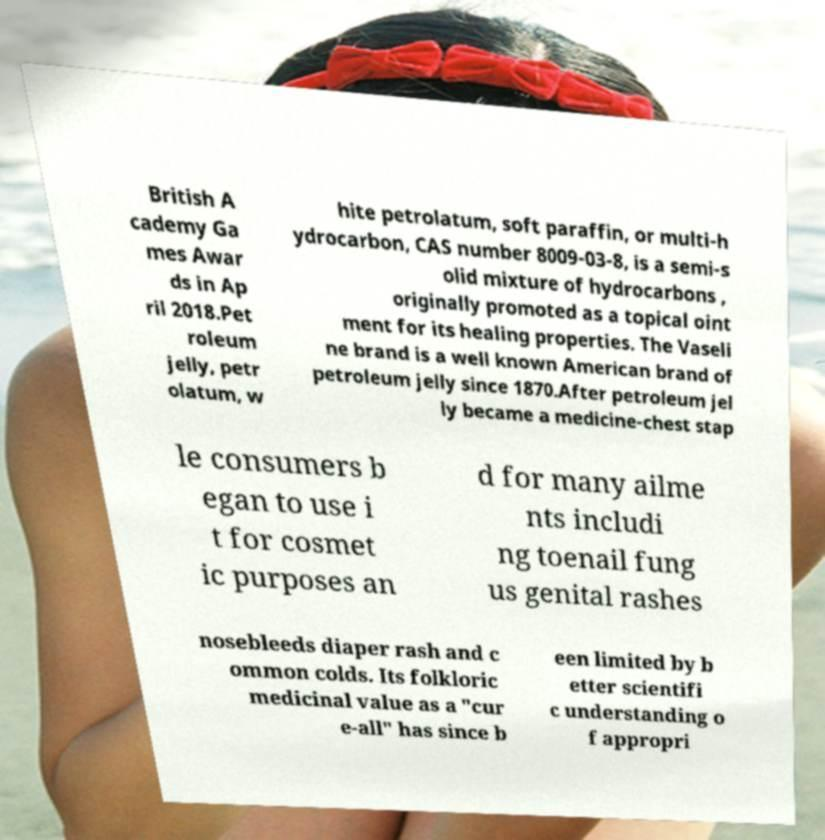Can you accurately transcribe the text from the provided image for me? British A cademy Ga mes Awar ds in Ap ril 2018.Pet roleum jelly, petr olatum, w hite petrolatum, soft paraffin, or multi-h ydrocarbon, CAS number 8009-03-8, is a semi-s olid mixture of hydrocarbons , originally promoted as a topical oint ment for its healing properties. The Vaseli ne brand is a well known American brand of petroleum jelly since 1870.After petroleum jel ly became a medicine-chest stap le consumers b egan to use i t for cosmet ic purposes an d for many ailme nts includi ng toenail fung us genital rashes nosebleeds diaper rash and c ommon colds. Its folkloric medicinal value as a "cur e-all" has since b een limited by b etter scientifi c understanding o f appropri 